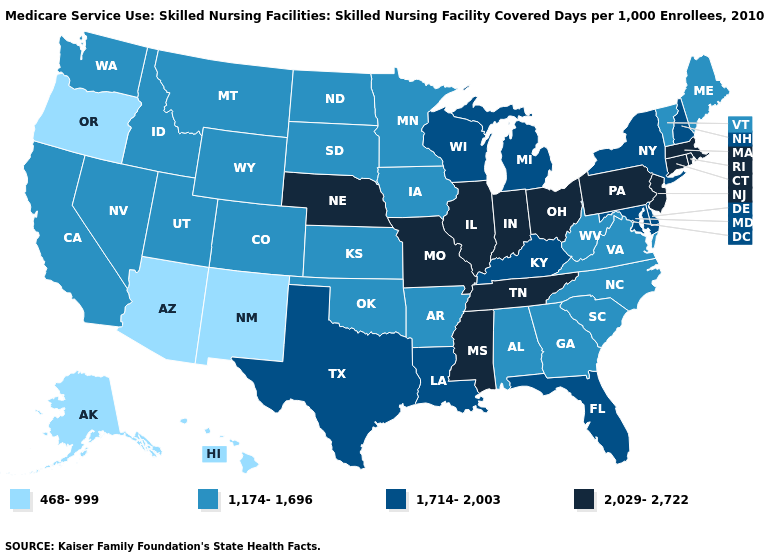What is the value of Colorado?
Quick response, please. 1,174-1,696. What is the value of Virginia?
Concise answer only. 1,174-1,696. Name the states that have a value in the range 1,714-2,003?
Be succinct. Delaware, Florida, Kentucky, Louisiana, Maryland, Michigan, New Hampshire, New York, Texas, Wisconsin. What is the value of Montana?
Quick response, please. 1,174-1,696. Does the map have missing data?
Write a very short answer. No. What is the value of Connecticut?
Be succinct. 2,029-2,722. Does the map have missing data?
Write a very short answer. No. Among the states that border Idaho , does Utah have the highest value?
Be succinct. Yes. Is the legend a continuous bar?
Answer briefly. No. What is the highest value in the USA?
Be succinct. 2,029-2,722. Does the map have missing data?
Give a very brief answer. No. What is the value of Georgia?
Be succinct. 1,174-1,696. Name the states that have a value in the range 1,714-2,003?
Short answer required. Delaware, Florida, Kentucky, Louisiana, Maryland, Michigan, New Hampshire, New York, Texas, Wisconsin. What is the value of Pennsylvania?
Short answer required. 2,029-2,722. Is the legend a continuous bar?
Quick response, please. No. 